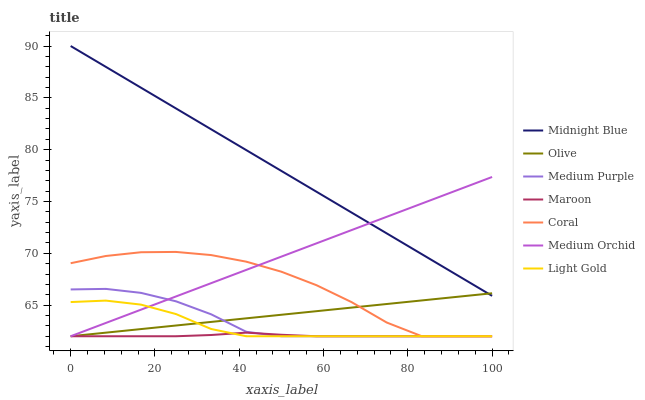Does Maroon have the minimum area under the curve?
Answer yes or no. Yes. Does Coral have the minimum area under the curve?
Answer yes or no. No. Does Coral have the maximum area under the curve?
Answer yes or no. No. Is Medium Orchid the smoothest?
Answer yes or no. Yes. Is Coral the roughest?
Answer yes or no. Yes. Is Coral the smoothest?
Answer yes or no. No. Is Medium Orchid the roughest?
Answer yes or no. No. Does Coral have the highest value?
Answer yes or no. No. Is Light Gold less than Midnight Blue?
Answer yes or no. Yes. Is Midnight Blue greater than Medium Purple?
Answer yes or no. Yes. Does Light Gold intersect Midnight Blue?
Answer yes or no. No. 